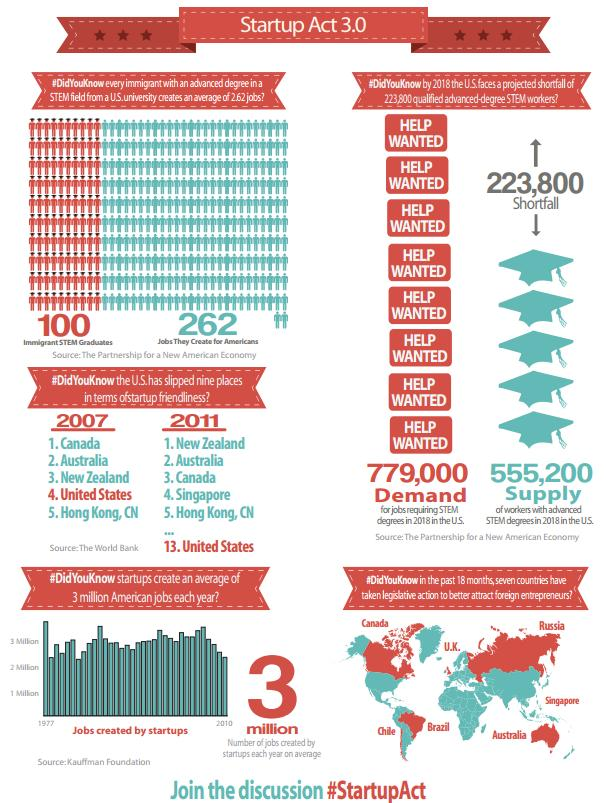Specify some key components in this picture. In the last 18 months, the North Asian country of Singapore has enacted laws aimed at attracting foreign entrepreneurs. In 2011, it was determined that New Zealand was the most startup-friendly state. In 2007 and 2011, Australia was ranked second in startup friendliness among all countries. In the last 18 months, two countries in Latin America have enacted legislation to encourage foreign entrepreneurs to invest in their economies. In the 1977-2010 period, the year that startups created the most number of jobs was 1977. 